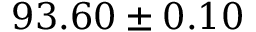Convert formula to latex. <formula><loc_0><loc_0><loc_500><loc_500>9 3 . 6 0 \pm 0 . 1 0</formula> 